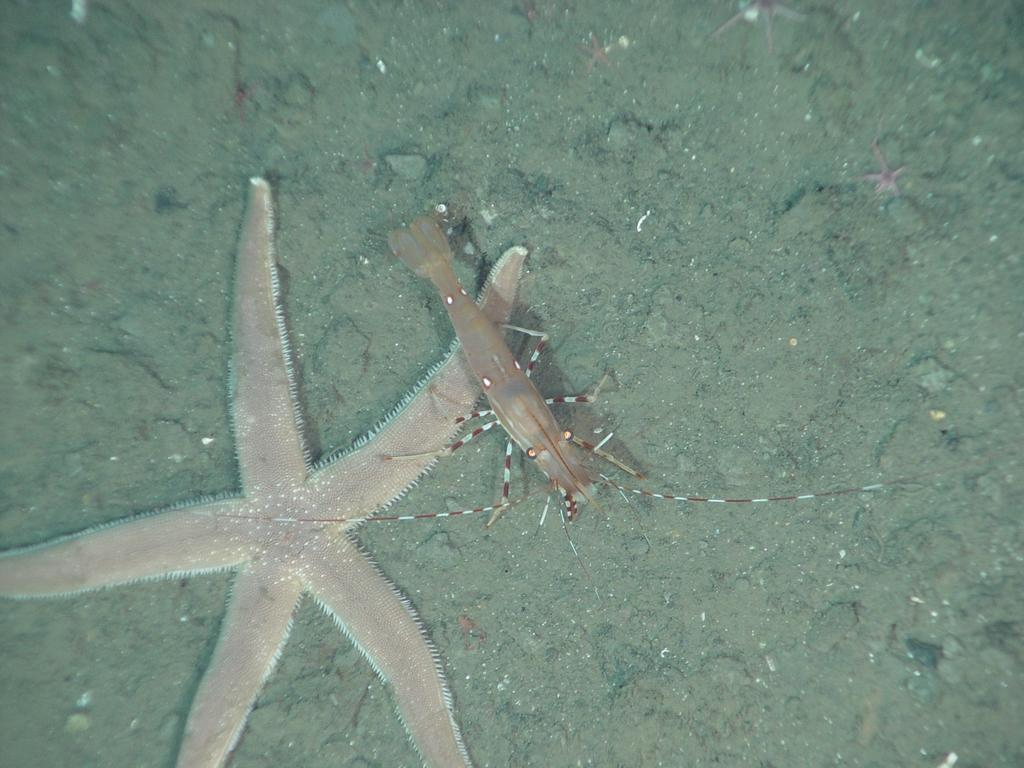What type of sea creature can be seen in the image? There is a starfish in the image. What other sea creature is present in the image? There is a prawn in the image. What type of surface is visible in the image? There is soil visible in the image. What type of objects can be seen on the floor in the image? There are stones on the floor in the image. What time does the clock show in the image? There is no clock present in the image. What type of box can be seen in the image? There is no box present in the image. 